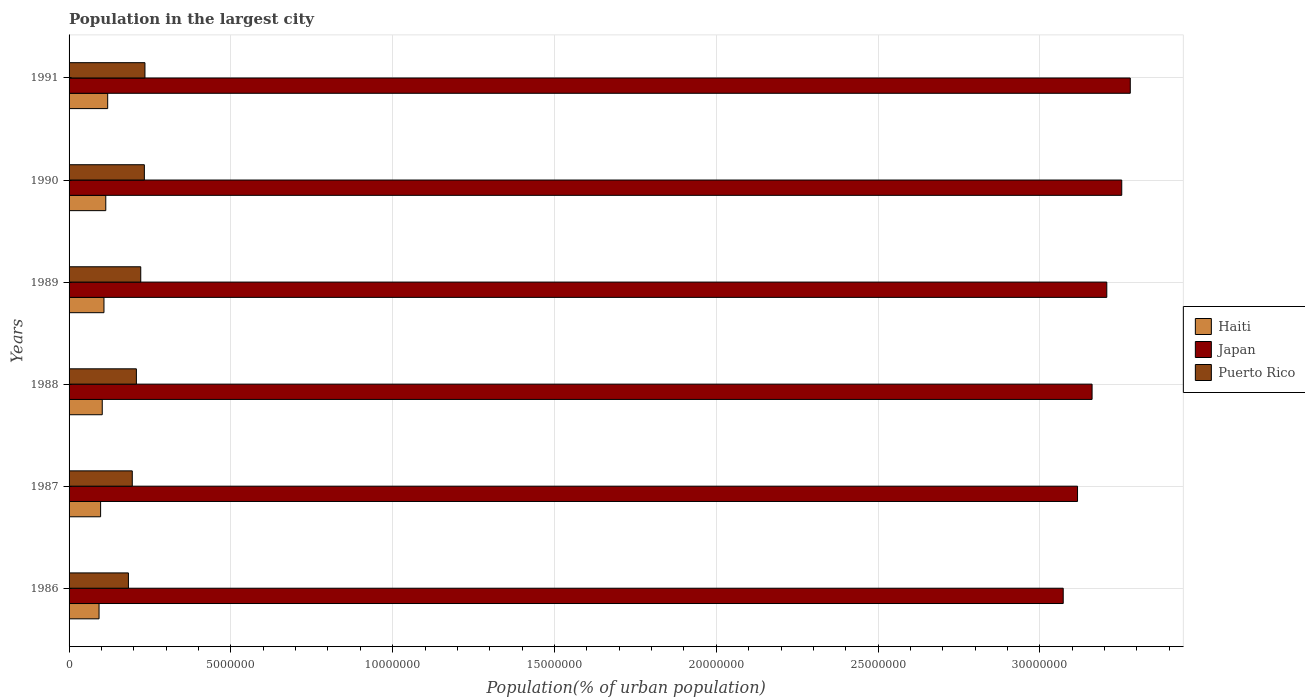How many different coloured bars are there?
Provide a short and direct response. 3. Are the number of bars per tick equal to the number of legend labels?
Provide a short and direct response. Yes. How many bars are there on the 1st tick from the bottom?
Keep it short and to the point. 3. In how many cases, is the number of bars for a given year not equal to the number of legend labels?
Make the answer very short. 0. What is the population in the largest city in Puerto Rico in 1987?
Provide a short and direct response. 1.95e+06. Across all years, what is the maximum population in the largest city in Japan?
Your answer should be very brief. 3.28e+07. Across all years, what is the minimum population in the largest city in Japan?
Provide a short and direct response. 3.07e+07. In which year was the population in the largest city in Haiti minimum?
Ensure brevity in your answer.  1986. What is the total population in the largest city in Puerto Rico in the graph?
Ensure brevity in your answer.  1.28e+07. What is the difference between the population in the largest city in Haiti in 1986 and that in 1991?
Ensure brevity in your answer.  -2.67e+05. What is the difference between the population in the largest city in Japan in 1989 and the population in the largest city in Haiti in 1986?
Ensure brevity in your answer.  3.11e+07. What is the average population in the largest city in Puerto Rico per year?
Provide a succinct answer. 2.13e+06. In the year 1988, what is the difference between the population in the largest city in Japan and population in the largest city in Haiti?
Make the answer very short. 3.06e+07. What is the ratio of the population in the largest city in Japan in 1986 to that in 1989?
Make the answer very short. 0.96. Is the population in the largest city in Haiti in 1986 less than that in 1989?
Provide a short and direct response. Yes. What is the difference between the highest and the second highest population in the largest city in Haiti?
Ensure brevity in your answer.  5.88e+04. What is the difference between the highest and the lowest population in the largest city in Haiti?
Your answer should be very brief. 2.67e+05. In how many years, is the population in the largest city in Puerto Rico greater than the average population in the largest city in Puerto Rico taken over all years?
Offer a terse response. 3. Is the sum of the population in the largest city in Japan in 1988 and 1990 greater than the maximum population in the largest city in Haiti across all years?
Your answer should be very brief. Yes. What does the 3rd bar from the bottom in 1991 represents?
Provide a succinct answer. Puerto Rico. Is it the case that in every year, the sum of the population in the largest city in Puerto Rico and population in the largest city in Japan is greater than the population in the largest city in Haiti?
Provide a short and direct response. Yes. How many bars are there?
Provide a short and direct response. 18. Are all the bars in the graph horizontal?
Provide a short and direct response. Yes. How many years are there in the graph?
Offer a very short reply. 6. What is the difference between two consecutive major ticks on the X-axis?
Your response must be concise. 5.00e+06. Does the graph contain grids?
Give a very brief answer. Yes. How are the legend labels stacked?
Your response must be concise. Vertical. What is the title of the graph?
Your response must be concise. Population in the largest city. What is the label or title of the X-axis?
Provide a short and direct response. Population(% of urban population). What is the Population(% of urban population) of Haiti in 1986?
Provide a short and direct response. 9.27e+05. What is the Population(% of urban population) of Japan in 1986?
Provide a short and direct response. 3.07e+07. What is the Population(% of urban population) of Puerto Rico in 1986?
Your answer should be very brief. 1.83e+06. What is the Population(% of urban population) in Haiti in 1987?
Your answer should be compact. 9.75e+05. What is the Population(% of urban population) in Japan in 1987?
Provide a succinct answer. 3.12e+07. What is the Population(% of urban population) of Puerto Rico in 1987?
Ensure brevity in your answer.  1.95e+06. What is the Population(% of urban population) of Haiti in 1988?
Make the answer very short. 1.03e+06. What is the Population(% of urban population) in Japan in 1988?
Your answer should be very brief. 3.16e+07. What is the Population(% of urban population) in Puerto Rico in 1988?
Provide a short and direct response. 2.08e+06. What is the Population(% of urban population) in Haiti in 1989?
Offer a terse response. 1.08e+06. What is the Population(% of urban population) of Japan in 1989?
Offer a very short reply. 3.21e+07. What is the Population(% of urban population) in Puerto Rico in 1989?
Provide a succinct answer. 2.22e+06. What is the Population(% of urban population) in Haiti in 1990?
Your answer should be compact. 1.13e+06. What is the Population(% of urban population) in Japan in 1990?
Offer a terse response. 3.25e+07. What is the Population(% of urban population) in Puerto Rico in 1990?
Offer a very short reply. 2.33e+06. What is the Population(% of urban population) in Haiti in 1991?
Give a very brief answer. 1.19e+06. What is the Population(% of urban population) in Japan in 1991?
Provide a succinct answer. 3.28e+07. What is the Population(% of urban population) of Puerto Rico in 1991?
Keep it short and to the point. 2.34e+06. Across all years, what is the maximum Population(% of urban population) in Haiti?
Your response must be concise. 1.19e+06. Across all years, what is the maximum Population(% of urban population) in Japan?
Provide a succinct answer. 3.28e+07. Across all years, what is the maximum Population(% of urban population) in Puerto Rico?
Give a very brief answer. 2.34e+06. Across all years, what is the minimum Population(% of urban population) in Haiti?
Offer a terse response. 9.27e+05. Across all years, what is the minimum Population(% of urban population) in Japan?
Your answer should be very brief. 3.07e+07. Across all years, what is the minimum Population(% of urban population) in Puerto Rico?
Provide a succinct answer. 1.83e+06. What is the total Population(% of urban population) in Haiti in the graph?
Offer a terse response. 6.33e+06. What is the total Population(% of urban population) of Japan in the graph?
Keep it short and to the point. 1.91e+08. What is the total Population(% of urban population) in Puerto Rico in the graph?
Your answer should be very brief. 1.28e+07. What is the difference between the Population(% of urban population) in Haiti in 1986 and that in 1987?
Offer a terse response. -4.81e+04. What is the difference between the Population(% of urban population) in Japan in 1986 and that in 1987?
Offer a terse response. -4.43e+05. What is the difference between the Population(% of urban population) in Puerto Rico in 1986 and that in 1987?
Keep it short and to the point. -1.19e+05. What is the difference between the Population(% of urban population) in Haiti in 1986 and that in 1988?
Your answer should be compact. -9.87e+04. What is the difference between the Population(% of urban population) of Japan in 1986 and that in 1988?
Ensure brevity in your answer.  -8.92e+05. What is the difference between the Population(% of urban population) of Puerto Rico in 1986 and that in 1988?
Provide a short and direct response. -2.46e+05. What is the difference between the Population(% of urban population) of Haiti in 1986 and that in 1989?
Keep it short and to the point. -1.52e+05. What is the difference between the Population(% of urban population) in Japan in 1986 and that in 1989?
Ensure brevity in your answer.  -1.35e+06. What is the difference between the Population(% of urban population) in Puerto Rico in 1986 and that in 1989?
Your answer should be very brief. -3.81e+05. What is the difference between the Population(% of urban population) in Haiti in 1986 and that in 1990?
Your answer should be very brief. -2.08e+05. What is the difference between the Population(% of urban population) of Japan in 1986 and that in 1990?
Provide a succinct answer. -1.81e+06. What is the difference between the Population(% of urban population) in Puerto Rico in 1986 and that in 1990?
Offer a terse response. -4.93e+05. What is the difference between the Population(% of urban population) of Haiti in 1986 and that in 1991?
Keep it short and to the point. -2.67e+05. What is the difference between the Population(% of urban population) of Japan in 1986 and that in 1991?
Offer a very short reply. -2.07e+06. What is the difference between the Population(% of urban population) of Puerto Rico in 1986 and that in 1991?
Offer a very short reply. -5.11e+05. What is the difference between the Population(% of urban population) in Haiti in 1987 and that in 1988?
Give a very brief answer. -5.06e+04. What is the difference between the Population(% of urban population) of Japan in 1987 and that in 1988?
Your response must be concise. -4.49e+05. What is the difference between the Population(% of urban population) in Puerto Rico in 1987 and that in 1988?
Give a very brief answer. -1.27e+05. What is the difference between the Population(% of urban population) of Haiti in 1987 and that in 1989?
Your response must be concise. -1.04e+05. What is the difference between the Population(% of urban population) in Japan in 1987 and that in 1989?
Give a very brief answer. -9.04e+05. What is the difference between the Population(% of urban population) in Puerto Rico in 1987 and that in 1989?
Ensure brevity in your answer.  -2.62e+05. What is the difference between the Population(% of urban population) in Haiti in 1987 and that in 1990?
Provide a succinct answer. -1.60e+05. What is the difference between the Population(% of urban population) in Japan in 1987 and that in 1990?
Your answer should be compact. -1.37e+06. What is the difference between the Population(% of urban population) in Puerto Rico in 1987 and that in 1990?
Make the answer very short. -3.74e+05. What is the difference between the Population(% of urban population) of Haiti in 1987 and that in 1991?
Your response must be concise. -2.18e+05. What is the difference between the Population(% of urban population) in Japan in 1987 and that in 1991?
Your answer should be very brief. -1.63e+06. What is the difference between the Population(% of urban population) of Puerto Rico in 1987 and that in 1991?
Your response must be concise. -3.92e+05. What is the difference between the Population(% of urban population) of Haiti in 1988 and that in 1989?
Offer a terse response. -5.31e+04. What is the difference between the Population(% of urban population) of Japan in 1988 and that in 1989?
Offer a terse response. -4.55e+05. What is the difference between the Population(% of urban population) in Puerto Rico in 1988 and that in 1989?
Your response must be concise. -1.35e+05. What is the difference between the Population(% of urban population) of Haiti in 1988 and that in 1990?
Keep it short and to the point. -1.09e+05. What is the difference between the Population(% of urban population) in Japan in 1988 and that in 1990?
Your response must be concise. -9.17e+05. What is the difference between the Population(% of urban population) in Puerto Rico in 1988 and that in 1990?
Keep it short and to the point. -2.47e+05. What is the difference between the Population(% of urban population) in Haiti in 1988 and that in 1991?
Your answer should be compact. -1.68e+05. What is the difference between the Population(% of urban population) of Japan in 1988 and that in 1991?
Provide a succinct answer. -1.18e+06. What is the difference between the Population(% of urban population) of Puerto Rico in 1988 and that in 1991?
Provide a short and direct response. -2.65e+05. What is the difference between the Population(% of urban population) in Haiti in 1989 and that in 1990?
Your answer should be compact. -5.59e+04. What is the difference between the Population(% of urban population) of Japan in 1989 and that in 1990?
Your answer should be compact. -4.62e+05. What is the difference between the Population(% of urban population) in Puerto Rico in 1989 and that in 1990?
Ensure brevity in your answer.  -1.12e+05. What is the difference between the Population(% of urban population) in Haiti in 1989 and that in 1991?
Provide a short and direct response. -1.15e+05. What is the difference between the Population(% of urban population) of Japan in 1989 and that in 1991?
Your answer should be compact. -7.26e+05. What is the difference between the Population(% of urban population) of Puerto Rico in 1989 and that in 1991?
Ensure brevity in your answer.  -1.30e+05. What is the difference between the Population(% of urban population) of Haiti in 1990 and that in 1991?
Offer a terse response. -5.88e+04. What is the difference between the Population(% of urban population) of Japan in 1990 and that in 1991?
Offer a very short reply. -2.64e+05. What is the difference between the Population(% of urban population) of Puerto Rico in 1990 and that in 1991?
Give a very brief answer. -1.81e+04. What is the difference between the Population(% of urban population) of Haiti in 1986 and the Population(% of urban population) of Japan in 1987?
Provide a short and direct response. -3.02e+07. What is the difference between the Population(% of urban population) of Haiti in 1986 and the Population(% of urban population) of Puerto Rico in 1987?
Ensure brevity in your answer.  -1.03e+06. What is the difference between the Population(% of urban population) in Japan in 1986 and the Population(% of urban population) in Puerto Rico in 1987?
Provide a short and direct response. 2.88e+07. What is the difference between the Population(% of urban population) of Haiti in 1986 and the Population(% of urban population) of Japan in 1988?
Provide a succinct answer. -3.07e+07. What is the difference between the Population(% of urban population) in Haiti in 1986 and the Population(% of urban population) in Puerto Rico in 1988?
Offer a very short reply. -1.15e+06. What is the difference between the Population(% of urban population) in Japan in 1986 and the Population(% of urban population) in Puerto Rico in 1988?
Make the answer very short. 2.86e+07. What is the difference between the Population(% of urban population) of Haiti in 1986 and the Population(% of urban population) of Japan in 1989?
Give a very brief answer. -3.11e+07. What is the difference between the Population(% of urban population) of Haiti in 1986 and the Population(% of urban population) of Puerto Rico in 1989?
Provide a succinct answer. -1.29e+06. What is the difference between the Population(% of urban population) of Japan in 1986 and the Population(% of urban population) of Puerto Rico in 1989?
Your response must be concise. 2.85e+07. What is the difference between the Population(% of urban population) of Haiti in 1986 and the Population(% of urban population) of Japan in 1990?
Keep it short and to the point. -3.16e+07. What is the difference between the Population(% of urban population) of Haiti in 1986 and the Population(% of urban population) of Puerto Rico in 1990?
Keep it short and to the point. -1.40e+06. What is the difference between the Population(% of urban population) in Japan in 1986 and the Population(% of urban population) in Puerto Rico in 1990?
Offer a very short reply. 2.84e+07. What is the difference between the Population(% of urban population) in Haiti in 1986 and the Population(% of urban population) in Japan in 1991?
Your response must be concise. -3.19e+07. What is the difference between the Population(% of urban population) of Haiti in 1986 and the Population(% of urban population) of Puerto Rico in 1991?
Give a very brief answer. -1.42e+06. What is the difference between the Population(% of urban population) of Japan in 1986 and the Population(% of urban population) of Puerto Rico in 1991?
Your answer should be very brief. 2.84e+07. What is the difference between the Population(% of urban population) in Haiti in 1987 and the Population(% of urban population) in Japan in 1988?
Ensure brevity in your answer.  -3.06e+07. What is the difference between the Population(% of urban population) of Haiti in 1987 and the Population(% of urban population) of Puerto Rico in 1988?
Your answer should be very brief. -1.11e+06. What is the difference between the Population(% of urban population) in Japan in 1987 and the Population(% of urban population) in Puerto Rico in 1988?
Offer a very short reply. 2.91e+07. What is the difference between the Population(% of urban population) of Haiti in 1987 and the Population(% of urban population) of Japan in 1989?
Make the answer very short. -3.11e+07. What is the difference between the Population(% of urban population) of Haiti in 1987 and the Population(% of urban population) of Puerto Rico in 1989?
Ensure brevity in your answer.  -1.24e+06. What is the difference between the Population(% of urban population) in Japan in 1987 and the Population(% of urban population) in Puerto Rico in 1989?
Give a very brief answer. 2.89e+07. What is the difference between the Population(% of urban population) in Haiti in 1987 and the Population(% of urban population) in Japan in 1990?
Give a very brief answer. -3.16e+07. What is the difference between the Population(% of urban population) in Haiti in 1987 and the Population(% of urban population) in Puerto Rico in 1990?
Your response must be concise. -1.35e+06. What is the difference between the Population(% of urban population) in Japan in 1987 and the Population(% of urban population) in Puerto Rico in 1990?
Give a very brief answer. 2.88e+07. What is the difference between the Population(% of urban population) in Haiti in 1987 and the Population(% of urban population) in Japan in 1991?
Make the answer very short. -3.18e+07. What is the difference between the Population(% of urban population) of Haiti in 1987 and the Population(% of urban population) of Puerto Rico in 1991?
Provide a short and direct response. -1.37e+06. What is the difference between the Population(% of urban population) in Japan in 1987 and the Population(% of urban population) in Puerto Rico in 1991?
Your answer should be compact. 2.88e+07. What is the difference between the Population(% of urban population) of Haiti in 1988 and the Population(% of urban population) of Japan in 1989?
Your answer should be very brief. -3.10e+07. What is the difference between the Population(% of urban population) of Haiti in 1988 and the Population(% of urban population) of Puerto Rico in 1989?
Ensure brevity in your answer.  -1.19e+06. What is the difference between the Population(% of urban population) in Japan in 1988 and the Population(% of urban population) in Puerto Rico in 1989?
Your answer should be very brief. 2.94e+07. What is the difference between the Population(% of urban population) of Haiti in 1988 and the Population(% of urban population) of Japan in 1990?
Provide a short and direct response. -3.15e+07. What is the difference between the Population(% of urban population) in Haiti in 1988 and the Population(% of urban population) in Puerto Rico in 1990?
Your answer should be compact. -1.30e+06. What is the difference between the Population(% of urban population) of Japan in 1988 and the Population(% of urban population) of Puerto Rico in 1990?
Offer a terse response. 2.93e+07. What is the difference between the Population(% of urban population) of Haiti in 1988 and the Population(% of urban population) of Japan in 1991?
Make the answer very short. -3.18e+07. What is the difference between the Population(% of urban population) of Haiti in 1988 and the Population(% of urban population) of Puerto Rico in 1991?
Make the answer very short. -1.32e+06. What is the difference between the Population(% of urban population) in Japan in 1988 and the Population(% of urban population) in Puerto Rico in 1991?
Your answer should be very brief. 2.93e+07. What is the difference between the Population(% of urban population) of Haiti in 1989 and the Population(% of urban population) of Japan in 1990?
Offer a very short reply. -3.15e+07. What is the difference between the Population(% of urban population) in Haiti in 1989 and the Population(% of urban population) in Puerto Rico in 1990?
Offer a terse response. -1.25e+06. What is the difference between the Population(% of urban population) in Japan in 1989 and the Population(% of urban population) in Puerto Rico in 1990?
Offer a terse response. 2.97e+07. What is the difference between the Population(% of urban population) in Haiti in 1989 and the Population(% of urban population) in Japan in 1991?
Make the answer very short. -3.17e+07. What is the difference between the Population(% of urban population) in Haiti in 1989 and the Population(% of urban population) in Puerto Rico in 1991?
Provide a short and direct response. -1.27e+06. What is the difference between the Population(% of urban population) of Japan in 1989 and the Population(% of urban population) of Puerto Rico in 1991?
Make the answer very short. 2.97e+07. What is the difference between the Population(% of urban population) in Haiti in 1990 and the Population(% of urban population) in Japan in 1991?
Make the answer very short. -3.17e+07. What is the difference between the Population(% of urban population) of Haiti in 1990 and the Population(% of urban population) of Puerto Rico in 1991?
Keep it short and to the point. -1.21e+06. What is the difference between the Population(% of urban population) in Japan in 1990 and the Population(% of urban population) in Puerto Rico in 1991?
Offer a very short reply. 3.02e+07. What is the average Population(% of urban population) of Haiti per year?
Your answer should be compact. 1.06e+06. What is the average Population(% of urban population) of Japan per year?
Your answer should be compact. 3.18e+07. What is the average Population(% of urban population) of Puerto Rico per year?
Provide a succinct answer. 2.13e+06. In the year 1986, what is the difference between the Population(% of urban population) of Haiti and Population(% of urban population) of Japan?
Provide a succinct answer. -2.98e+07. In the year 1986, what is the difference between the Population(% of urban population) in Haiti and Population(% of urban population) in Puerto Rico?
Your answer should be compact. -9.08e+05. In the year 1986, what is the difference between the Population(% of urban population) in Japan and Population(% of urban population) in Puerto Rico?
Keep it short and to the point. 2.89e+07. In the year 1987, what is the difference between the Population(% of urban population) of Haiti and Population(% of urban population) of Japan?
Make the answer very short. -3.02e+07. In the year 1987, what is the difference between the Population(% of urban population) of Haiti and Population(% of urban population) of Puerto Rico?
Keep it short and to the point. -9.79e+05. In the year 1987, what is the difference between the Population(% of urban population) in Japan and Population(% of urban population) in Puerto Rico?
Your answer should be compact. 2.92e+07. In the year 1988, what is the difference between the Population(% of urban population) in Haiti and Population(% of urban population) in Japan?
Your answer should be very brief. -3.06e+07. In the year 1988, what is the difference between the Population(% of urban population) in Haiti and Population(% of urban population) in Puerto Rico?
Offer a very short reply. -1.06e+06. In the year 1988, what is the difference between the Population(% of urban population) in Japan and Population(% of urban population) in Puerto Rico?
Your answer should be very brief. 2.95e+07. In the year 1989, what is the difference between the Population(% of urban population) of Haiti and Population(% of urban population) of Japan?
Your answer should be compact. -3.10e+07. In the year 1989, what is the difference between the Population(% of urban population) of Haiti and Population(% of urban population) of Puerto Rico?
Keep it short and to the point. -1.14e+06. In the year 1989, what is the difference between the Population(% of urban population) of Japan and Population(% of urban population) of Puerto Rico?
Ensure brevity in your answer.  2.99e+07. In the year 1990, what is the difference between the Population(% of urban population) of Haiti and Population(% of urban population) of Japan?
Provide a short and direct response. -3.14e+07. In the year 1990, what is the difference between the Population(% of urban population) of Haiti and Population(% of urban population) of Puerto Rico?
Provide a succinct answer. -1.19e+06. In the year 1990, what is the difference between the Population(% of urban population) in Japan and Population(% of urban population) in Puerto Rico?
Offer a very short reply. 3.02e+07. In the year 1991, what is the difference between the Population(% of urban population) in Haiti and Population(% of urban population) in Japan?
Provide a short and direct response. -3.16e+07. In the year 1991, what is the difference between the Population(% of urban population) of Haiti and Population(% of urban population) of Puerto Rico?
Provide a short and direct response. -1.15e+06. In the year 1991, what is the difference between the Population(% of urban population) in Japan and Population(% of urban population) in Puerto Rico?
Provide a succinct answer. 3.04e+07. What is the ratio of the Population(% of urban population) of Haiti in 1986 to that in 1987?
Your answer should be compact. 0.95. What is the ratio of the Population(% of urban population) of Japan in 1986 to that in 1987?
Provide a succinct answer. 0.99. What is the ratio of the Population(% of urban population) in Puerto Rico in 1986 to that in 1987?
Offer a very short reply. 0.94. What is the ratio of the Population(% of urban population) of Haiti in 1986 to that in 1988?
Offer a terse response. 0.9. What is the ratio of the Population(% of urban population) of Japan in 1986 to that in 1988?
Provide a succinct answer. 0.97. What is the ratio of the Population(% of urban population) of Puerto Rico in 1986 to that in 1988?
Provide a short and direct response. 0.88. What is the ratio of the Population(% of urban population) of Haiti in 1986 to that in 1989?
Provide a short and direct response. 0.86. What is the ratio of the Population(% of urban population) of Japan in 1986 to that in 1989?
Make the answer very short. 0.96. What is the ratio of the Population(% of urban population) in Puerto Rico in 1986 to that in 1989?
Your answer should be compact. 0.83. What is the ratio of the Population(% of urban population) of Haiti in 1986 to that in 1990?
Provide a short and direct response. 0.82. What is the ratio of the Population(% of urban population) in Japan in 1986 to that in 1990?
Your answer should be compact. 0.94. What is the ratio of the Population(% of urban population) of Puerto Rico in 1986 to that in 1990?
Your answer should be very brief. 0.79. What is the ratio of the Population(% of urban population) of Haiti in 1986 to that in 1991?
Offer a terse response. 0.78. What is the ratio of the Population(% of urban population) of Japan in 1986 to that in 1991?
Make the answer very short. 0.94. What is the ratio of the Population(% of urban population) in Puerto Rico in 1986 to that in 1991?
Your answer should be compact. 0.78. What is the ratio of the Population(% of urban population) of Haiti in 1987 to that in 1988?
Your answer should be very brief. 0.95. What is the ratio of the Population(% of urban population) in Japan in 1987 to that in 1988?
Your response must be concise. 0.99. What is the ratio of the Population(% of urban population) in Puerto Rico in 1987 to that in 1988?
Keep it short and to the point. 0.94. What is the ratio of the Population(% of urban population) in Haiti in 1987 to that in 1989?
Provide a succinct answer. 0.9. What is the ratio of the Population(% of urban population) of Japan in 1987 to that in 1989?
Make the answer very short. 0.97. What is the ratio of the Population(% of urban population) in Puerto Rico in 1987 to that in 1989?
Keep it short and to the point. 0.88. What is the ratio of the Population(% of urban population) in Haiti in 1987 to that in 1990?
Offer a terse response. 0.86. What is the ratio of the Population(% of urban population) in Japan in 1987 to that in 1990?
Provide a succinct answer. 0.96. What is the ratio of the Population(% of urban population) of Puerto Rico in 1987 to that in 1990?
Ensure brevity in your answer.  0.84. What is the ratio of the Population(% of urban population) of Haiti in 1987 to that in 1991?
Provide a short and direct response. 0.82. What is the ratio of the Population(% of urban population) in Japan in 1987 to that in 1991?
Your answer should be very brief. 0.95. What is the ratio of the Population(% of urban population) in Puerto Rico in 1987 to that in 1991?
Offer a terse response. 0.83. What is the ratio of the Population(% of urban population) of Haiti in 1988 to that in 1989?
Your response must be concise. 0.95. What is the ratio of the Population(% of urban population) in Japan in 1988 to that in 1989?
Offer a very short reply. 0.99. What is the ratio of the Population(% of urban population) in Puerto Rico in 1988 to that in 1989?
Give a very brief answer. 0.94. What is the ratio of the Population(% of urban population) in Haiti in 1988 to that in 1990?
Keep it short and to the point. 0.9. What is the ratio of the Population(% of urban population) in Japan in 1988 to that in 1990?
Provide a short and direct response. 0.97. What is the ratio of the Population(% of urban population) of Puerto Rico in 1988 to that in 1990?
Ensure brevity in your answer.  0.89. What is the ratio of the Population(% of urban population) in Haiti in 1988 to that in 1991?
Keep it short and to the point. 0.86. What is the ratio of the Population(% of urban population) of Japan in 1988 to that in 1991?
Keep it short and to the point. 0.96. What is the ratio of the Population(% of urban population) of Puerto Rico in 1988 to that in 1991?
Offer a terse response. 0.89. What is the ratio of the Population(% of urban population) of Haiti in 1989 to that in 1990?
Offer a very short reply. 0.95. What is the ratio of the Population(% of urban population) of Japan in 1989 to that in 1990?
Your answer should be very brief. 0.99. What is the ratio of the Population(% of urban population) in Haiti in 1989 to that in 1991?
Your response must be concise. 0.9. What is the ratio of the Population(% of urban population) of Japan in 1989 to that in 1991?
Provide a succinct answer. 0.98. What is the ratio of the Population(% of urban population) of Puerto Rico in 1989 to that in 1991?
Your answer should be very brief. 0.94. What is the ratio of the Population(% of urban population) in Haiti in 1990 to that in 1991?
Provide a short and direct response. 0.95. What is the ratio of the Population(% of urban population) in Japan in 1990 to that in 1991?
Your answer should be very brief. 0.99. What is the difference between the highest and the second highest Population(% of urban population) in Haiti?
Provide a short and direct response. 5.88e+04. What is the difference between the highest and the second highest Population(% of urban population) in Japan?
Make the answer very short. 2.64e+05. What is the difference between the highest and the second highest Population(% of urban population) in Puerto Rico?
Offer a terse response. 1.81e+04. What is the difference between the highest and the lowest Population(% of urban population) in Haiti?
Offer a very short reply. 2.67e+05. What is the difference between the highest and the lowest Population(% of urban population) of Japan?
Offer a terse response. 2.07e+06. What is the difference between the highest and the lowest Population(% of urban population) of Puerto Rico?
Your answer should be compact. 5.11e+05. 